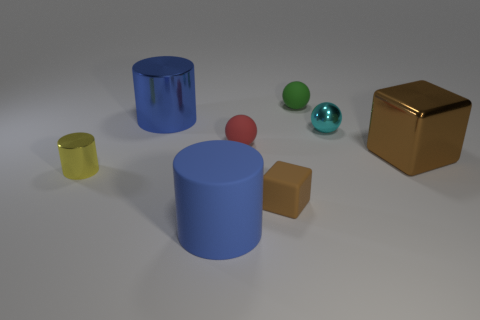Is there a large matte cylinder?
Make the answer very short. Yes. Is the number of yellow cylinders the same as the number of small brown metal objects?
Offer a very short reply. No. How many rubber cubes have the same color as the matte cylinder?
Provide a short and direct response. 0. Is the big block made of the same material as the large blue cylinder behind the tiny red rubber object?
Keep it short and to the point. Yes. Is the number of tiny green matte spheres that are behind the small red object greater than the number of small red matte spheres?
Keep it short and to the point. No. Is there any other thing that has the same size as the matte cylinder?
Provide a succinct answer. Yes. Do the shiny cube and the shiny cylinder on the right side of the small cylinder have the same color?
Provide a short and direct response. No. Are there an equal number of tiny yellow cylinders that are in front of the large rubber object and blue cylinders that are on the left side of the yellow metallic object?
Your answer should be very brief. Yes. What material is the big cylinder in front of the large metallic cube?
Ensure brevity in your answer.  Rubber. How many objects are either small metallic objects that are to the left of the cyan metallic sphere or tiny red rubber balls?
Keep it short and to the point. 2. 